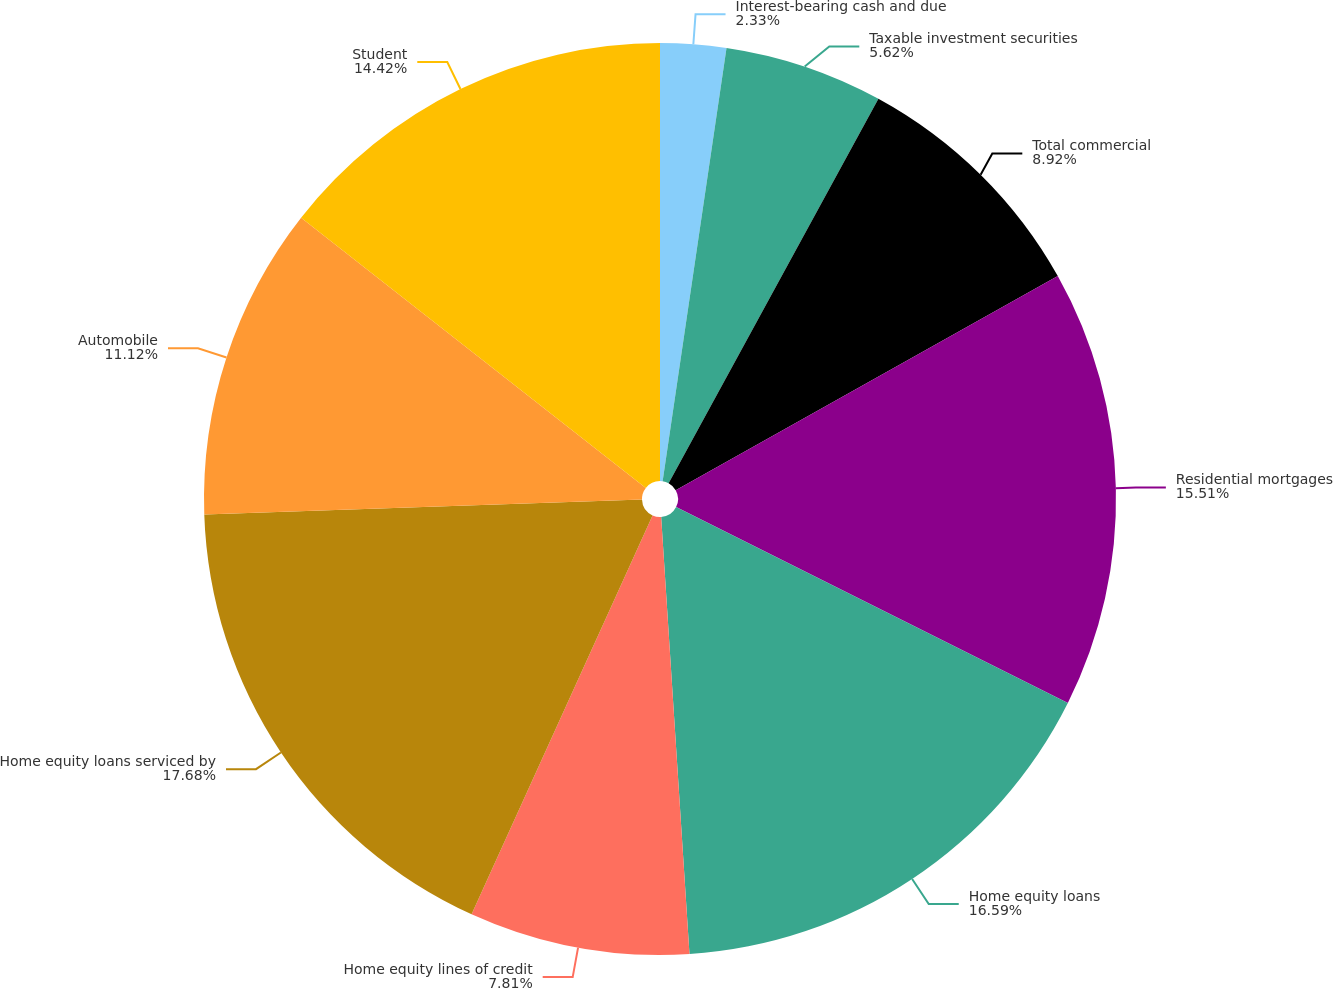Convert chart to OTSL. <chart><loc_0><loc_0><loc_500><loc_500><pie_chart><fcel>Interest-bearing cash and due<fcel>Taxable investment securities<fcel>Total commercial<fcel>Residential mortgages<fcel>Home equity loans<fcel>Home equity lines of credit<fcel>Home equity loans serviced by<fcel>Automobile<fcel>Student<nl><fcel>2.33%<fcel>5.62%<fcel>8.92%<fcel>15.51%<fcel>16.59%<fcel>7.81%<fcel>17.68%<fcel>11.12%<fcel>14.42%<nl></chart> 